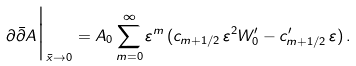Convert formula to latex. <formula><loc_0><loc_0><loc_500><loc_500>\partial \bar { \partial } A \Big | _ { \bar { x } \to 0 } = A _ { 0 } \sum _ { m = 0 } ^ { \infty } \varepsilon ^ { m } \, ( c _ { m + 1 / 2 } \, \varepsilon ^ { 2 } W ^ { \prime } _ { 0 } - c ^ { \prime } _ { m + 1 / 2 } \, \varepsilon ) \, .</formula> 